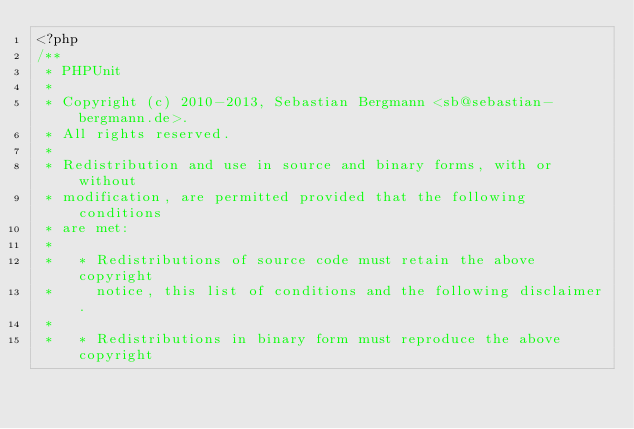<code> <loc_0><loc_0><loc_500><loc_500><_PHP_><?php
/**
 * PHPUnit
 *
 * Copyright (c) 2010-2013, Sebastian Bergmann <sb@sebastian-bergmann.de>.
 * All rights reserved.
 *
 * Redistribution and use in source and binary forms, with or without
 * modification, are permitted provided that the following conditions
 * are met:
 *
 *   * Redistributions of source code must retain the above copyright
 *     notice, this list of conditions and the following disclaimer.
 *
 *   * Redistributions in binary form must reproduce the above copyright</code> 